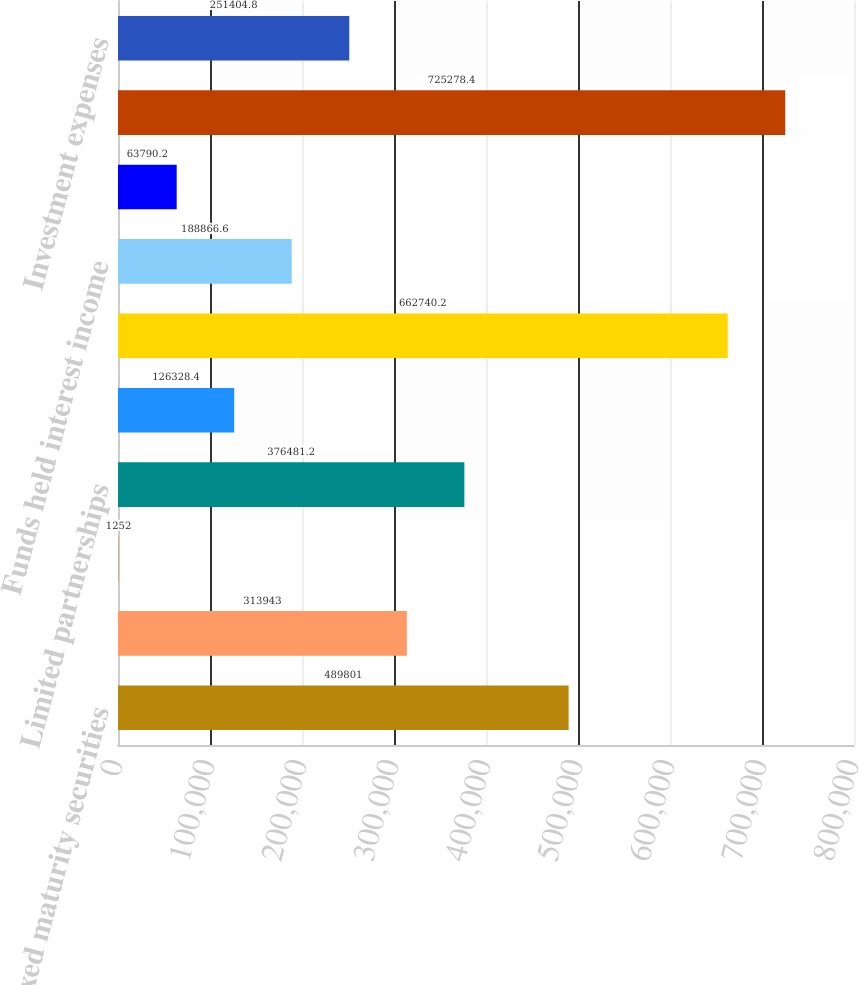<chart> <loc_0><loc_0><loc_500><loc_500><bar_chart><fcel>Fixed maturity securities<fcel>Equity securities<fcel>Short-term investments and<fcel>Limited partnerships<fcel>Other<fcel>Gross investment income before<fcel>Funds held interest income<fcel>Future policy benefit reserve<fcel>Gross investment income<fcel>Investment expenses<nl><fcel>489801<fcel>313943<fcel>1252<fcel>376481<fcel>126328<fcel>662740<fcel>188867<fcel>63790.2<fcel>725278<fcel>251405<nl></chart> 